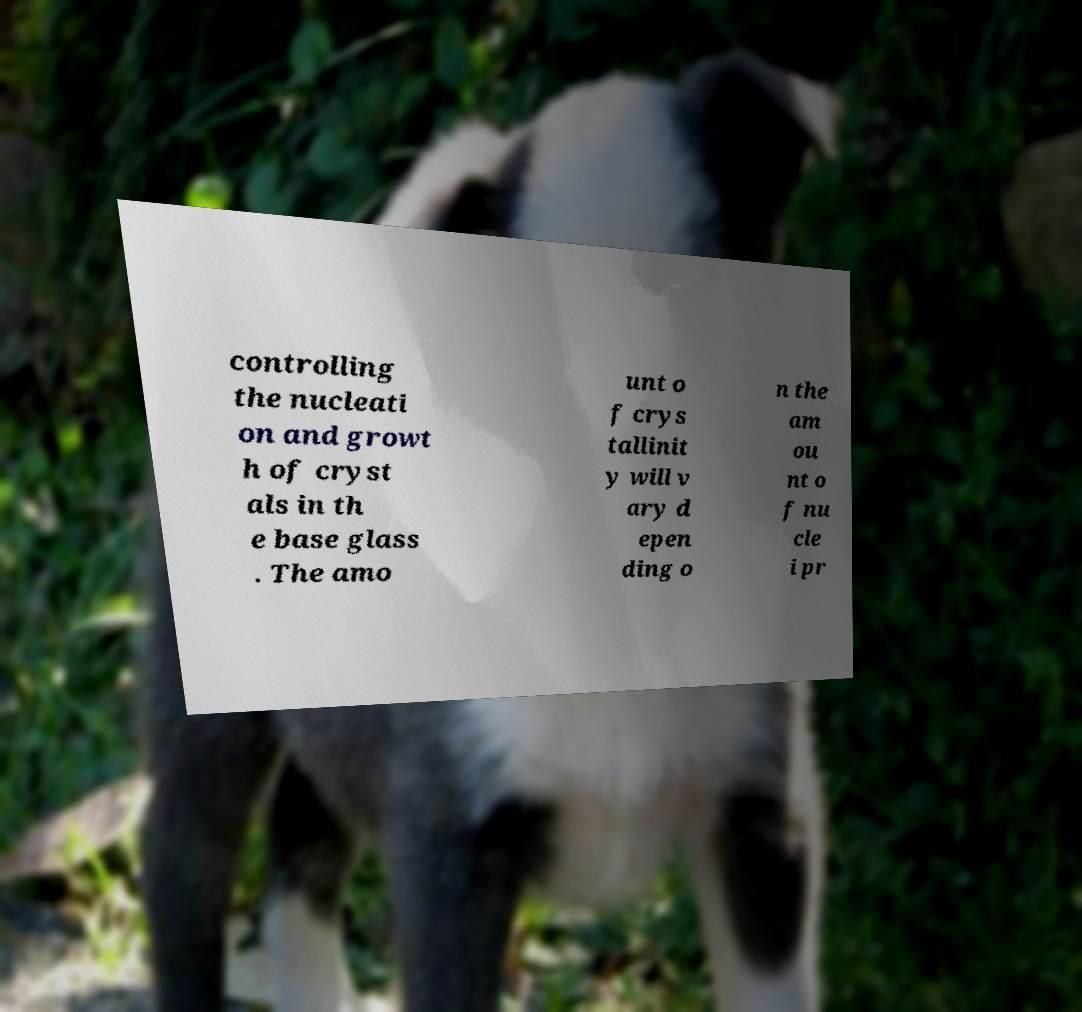I need the written content from this picture converted into text. Can you do that? controlling the nucleati on and growt h of cryst als in th e base glass . The amo unt o f crys tallinit y will v ary d epen ding o n the am ou nt o f nu cle i pr 